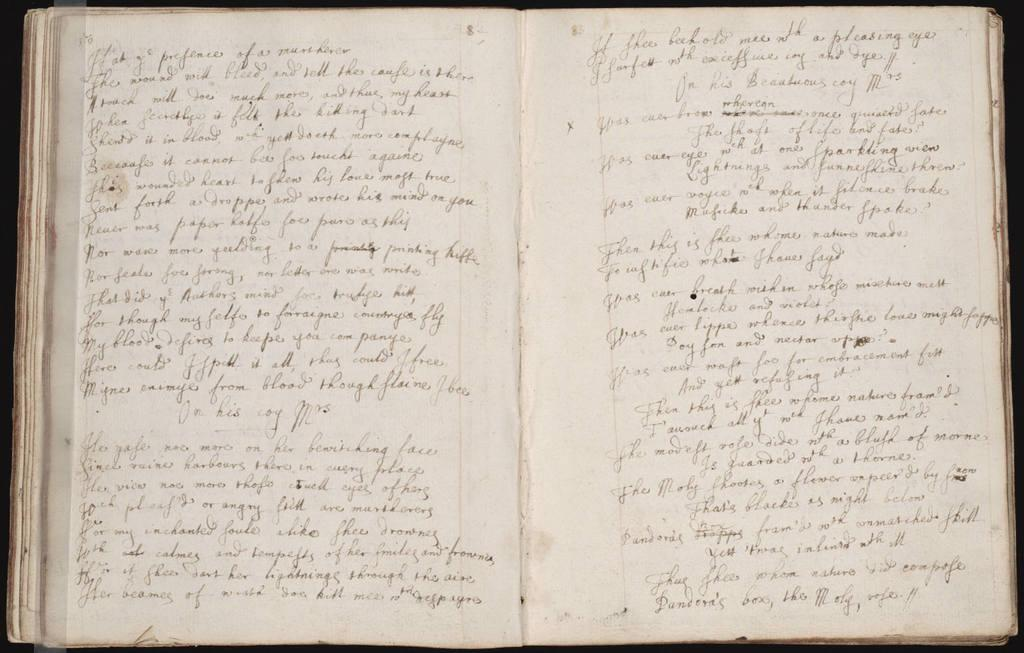What is the main subject of the picture? The main subject of the picture is an open book. What can be seen on the pages of the open book? There is writing on the open book. Can you see a cobweb on the pages of the book in the image? There is no cobweb visible on the pages of the book in the image. What is the title of the book in the image? The provided facts do not mention the title of the book, so it cannot be determined from the image. 